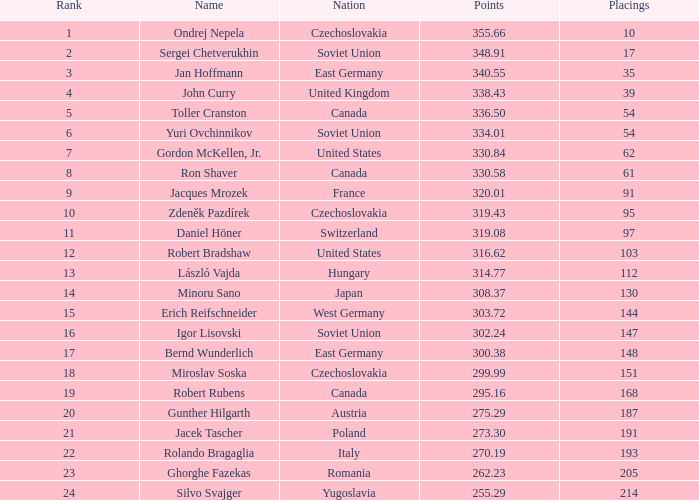Which Nation has Points of 300.38? East Germany. 